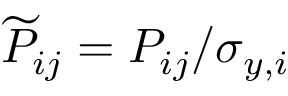<formula> <loc_0><loc_0><loc_500><loc_500>\widetilde { P } _ { i j } = P _ { i j } / \sigma _ { y , i }</formula> 